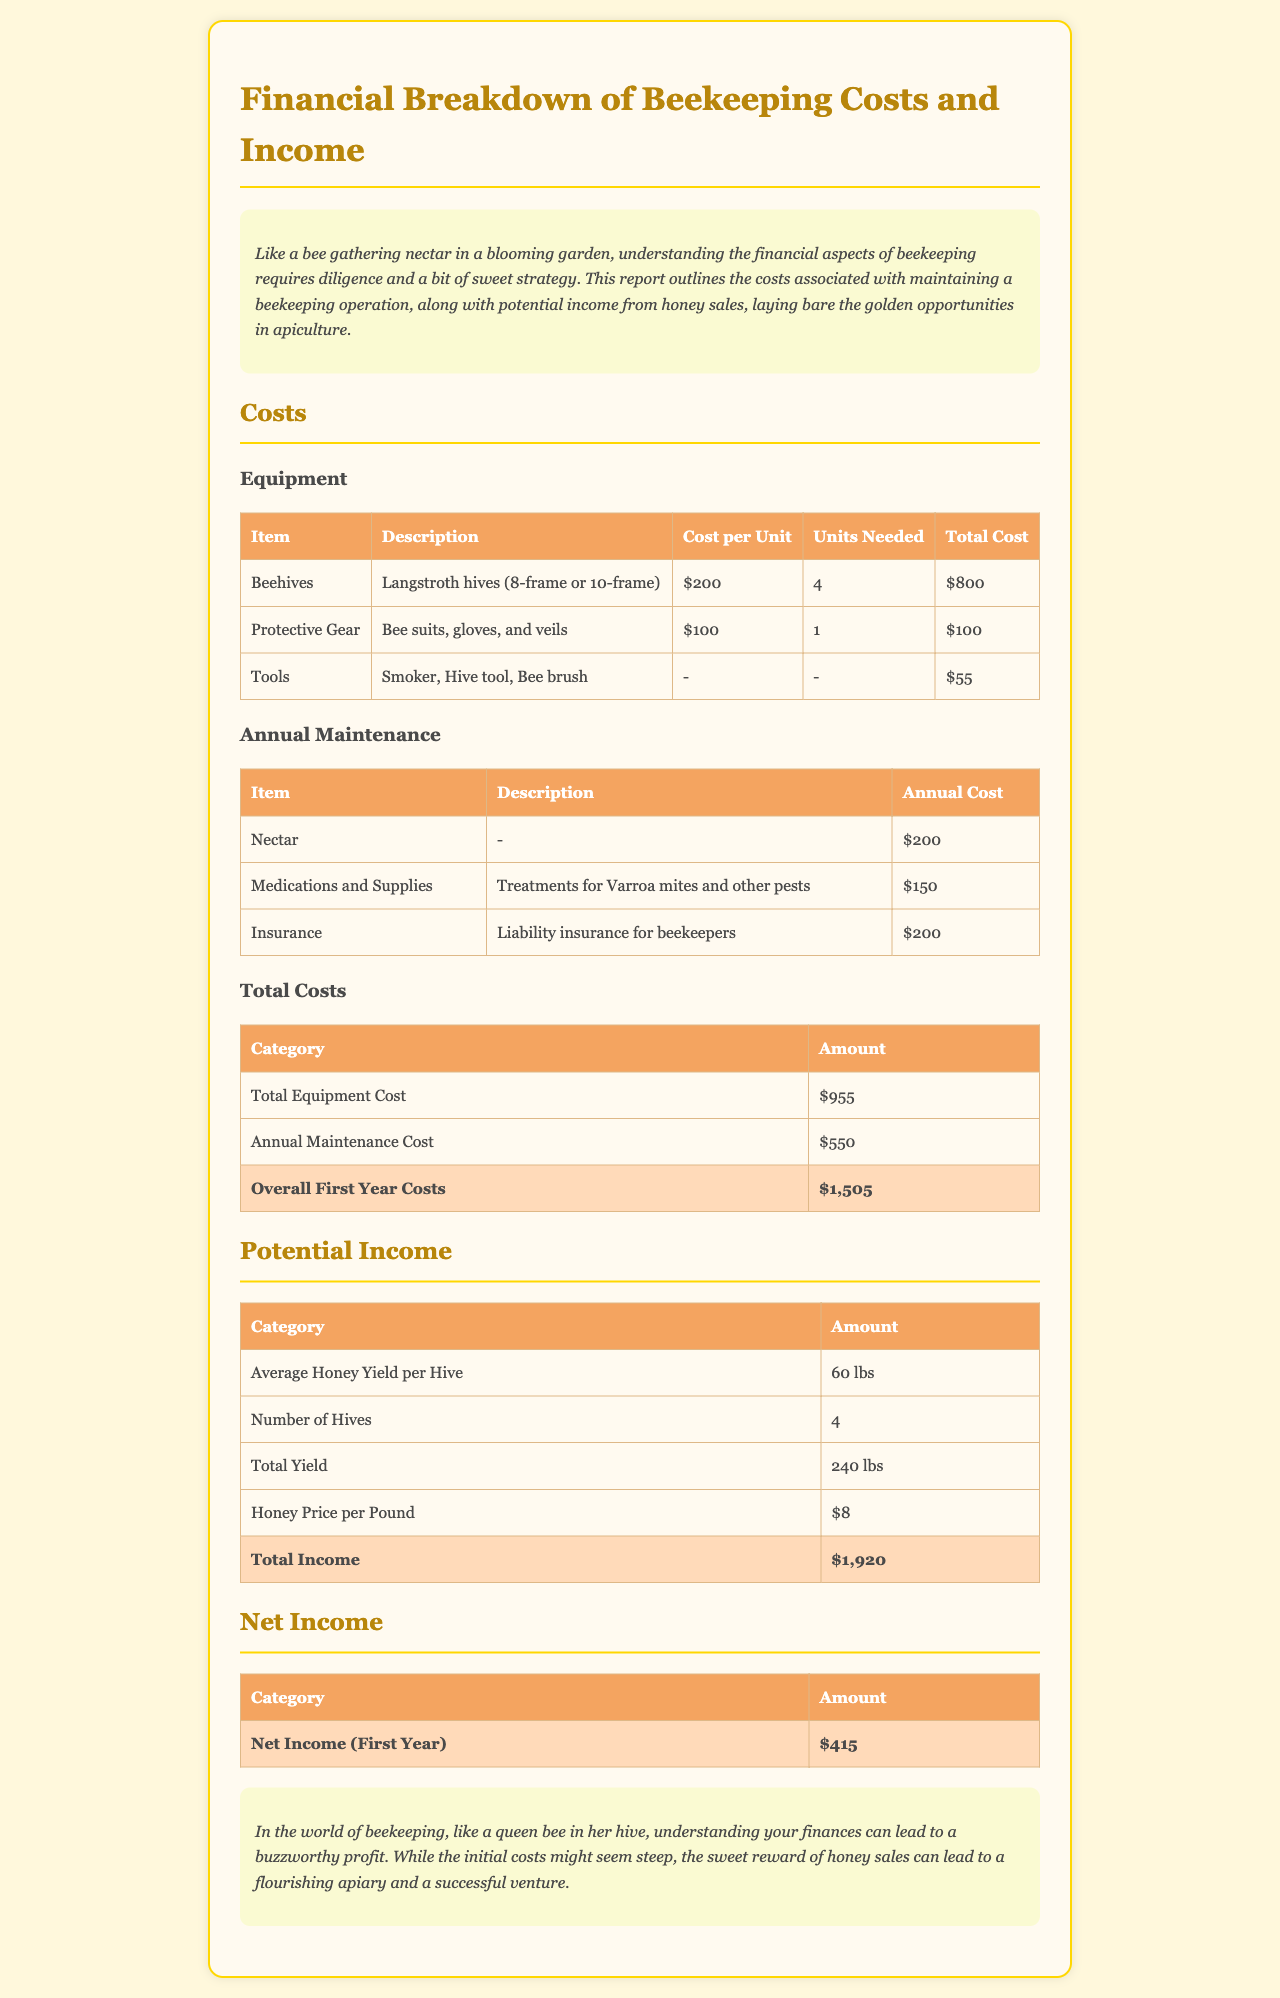What is the total cost of equipment? The total cost of equipment can be found in the "Total Costs" section and is stated as $955.
Answer: $955 How much does the Annual Maintenance cost? The Annual Maintenance Cost is listed in the "Total Costs" section as $550.
Answer: $550 What is the total income from honey sales? The total income derived from honey sales is highlighted in the "Potential Income" section as $1,920.
Answer: $1,920 How many hives are mentioned? The number of hives listed in the "Potential Income" section is 4.
Answer: 4 What is the net income for the first year? The net income for the first year is stated in the "Net Income" section as $415.
Answer: $415 What is the cost of protective gear? The cost for protective gear is found in the "Equipment" section and is listed as $100.
Answer: $100 How many pounds of honey does one hive yield on average? The average honey yield per hive is mentioned as 60 lbs in the "Potential Income" section.
Answer: 60 lbs What is the annual cost for medications and supplies? The annual cost for medications and supplies is highlighted as $150 in the "Annual Maintenance" section.
Answer: $150 What is the price of honey per pound? The price of honey per pound is shown in the "Potential Income" section as $8.
Answer: $8 